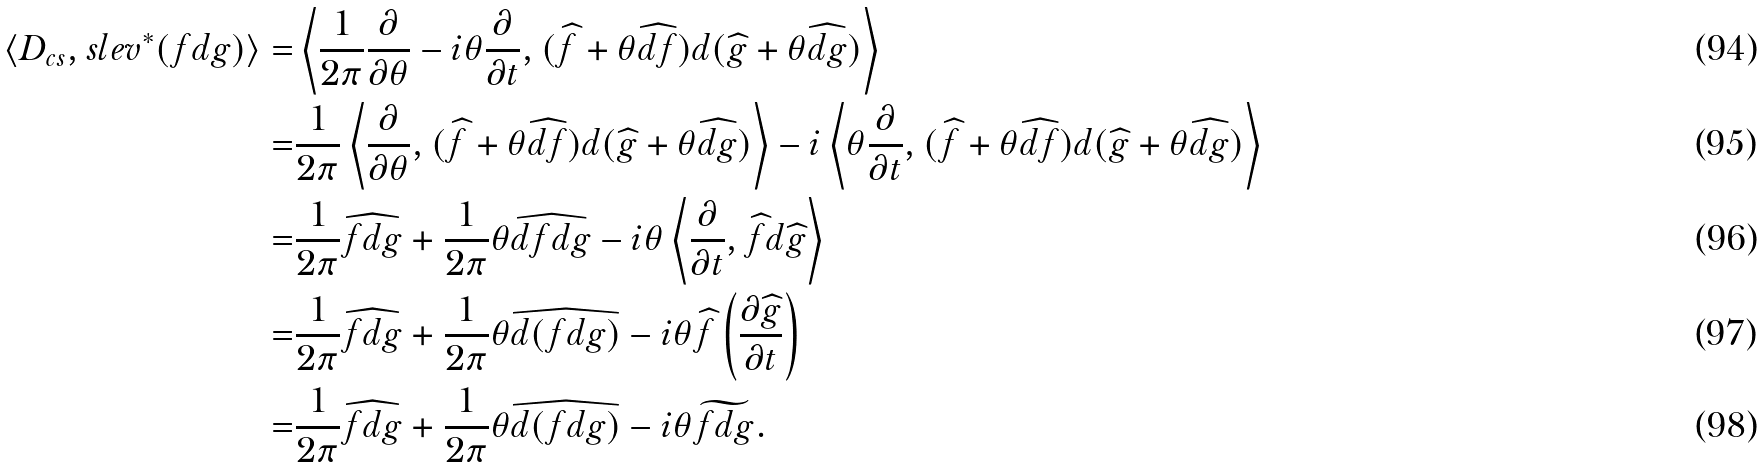Convert formula to latex. <formula><loc_0><loc_0><loc_500><loc_500>\langle D _ { c s } , s l e v ^ { * } ( f d g ) \rangle = & \left \langle \frac { 1 } { 2 \pi } \frac { \partial } { \partial \theta } - i \theta \frac { \partial } { \partial t } , ( \widehat { f } + \theta \widehat { d f } ) d ( \widehat { g } + \theta \widehat { d g } ) \right \rangle \\ = & \frac { 1 } { 2 \pi } \left \langle \frac { \partial } { \partial \theta } , ( \widehat { f } + \theta \widehat { d f } ) d ( \widehat { g } + \theta \widehat { d g } ) \right \rangle - i \left \langle \theta \frac { \partial } { \partial t } , ( \widehat { f } + \theta \widehat { d f } ) d ( \widehat { g } + \theta \widehat { d g } ) \right \rangle \\ = & \frac { 1 } { 2 \pi } \widehat { f d g } + \frac { 1 } { 2 \pi } \theta \widehat { d f d g } - i \theta \left \langle \frac { \partial } { \partial t } , \widehat { f } d \widehat { g } \right \rangle \\ = & \frac { 1 } { 2 \pi } \widehat { f d g } + \frac { 1 } { 2 \pi } \theta \widehat { d ( f d g ) } - i \theta \widehat { f } \left ( \frac { \partial \widehat { g } } { \partial t } \right ) \\ = & \frac { 1 } { 2 \pi } \widehat { f d g } + \frac { 1 } { 2 \pi } \theta \widehat { d ( f d g ) } - i \theta \widetilde { f d g } .</formula> 